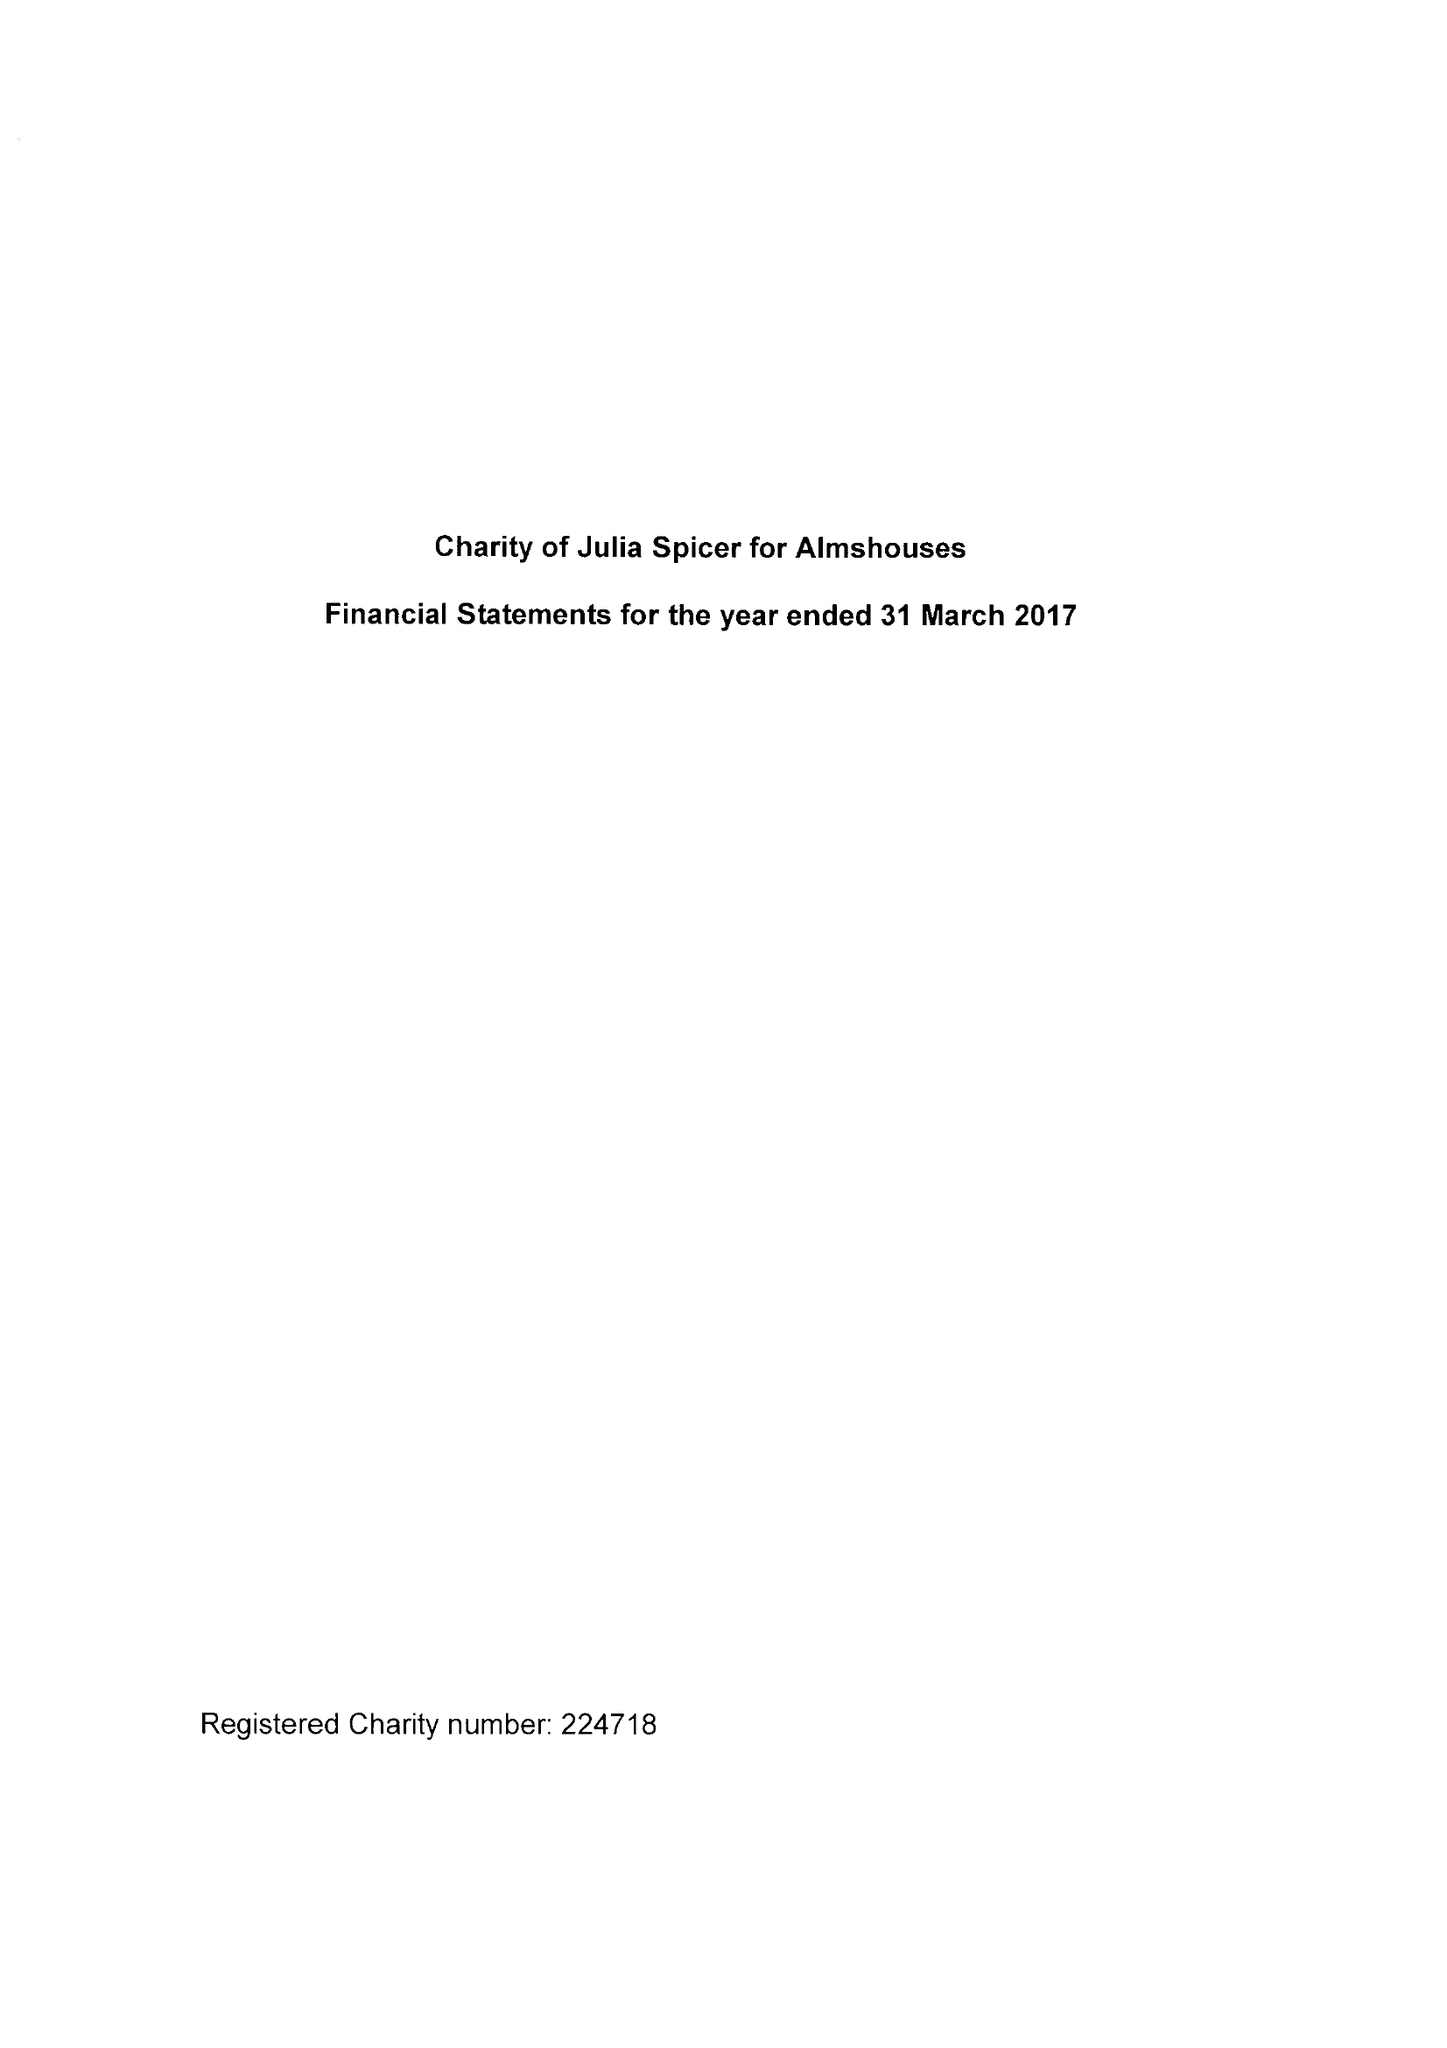What is the value for the charity_name?
Answer the question using a single word or phrase. Charity Of Julia Spicer For Almshouses 